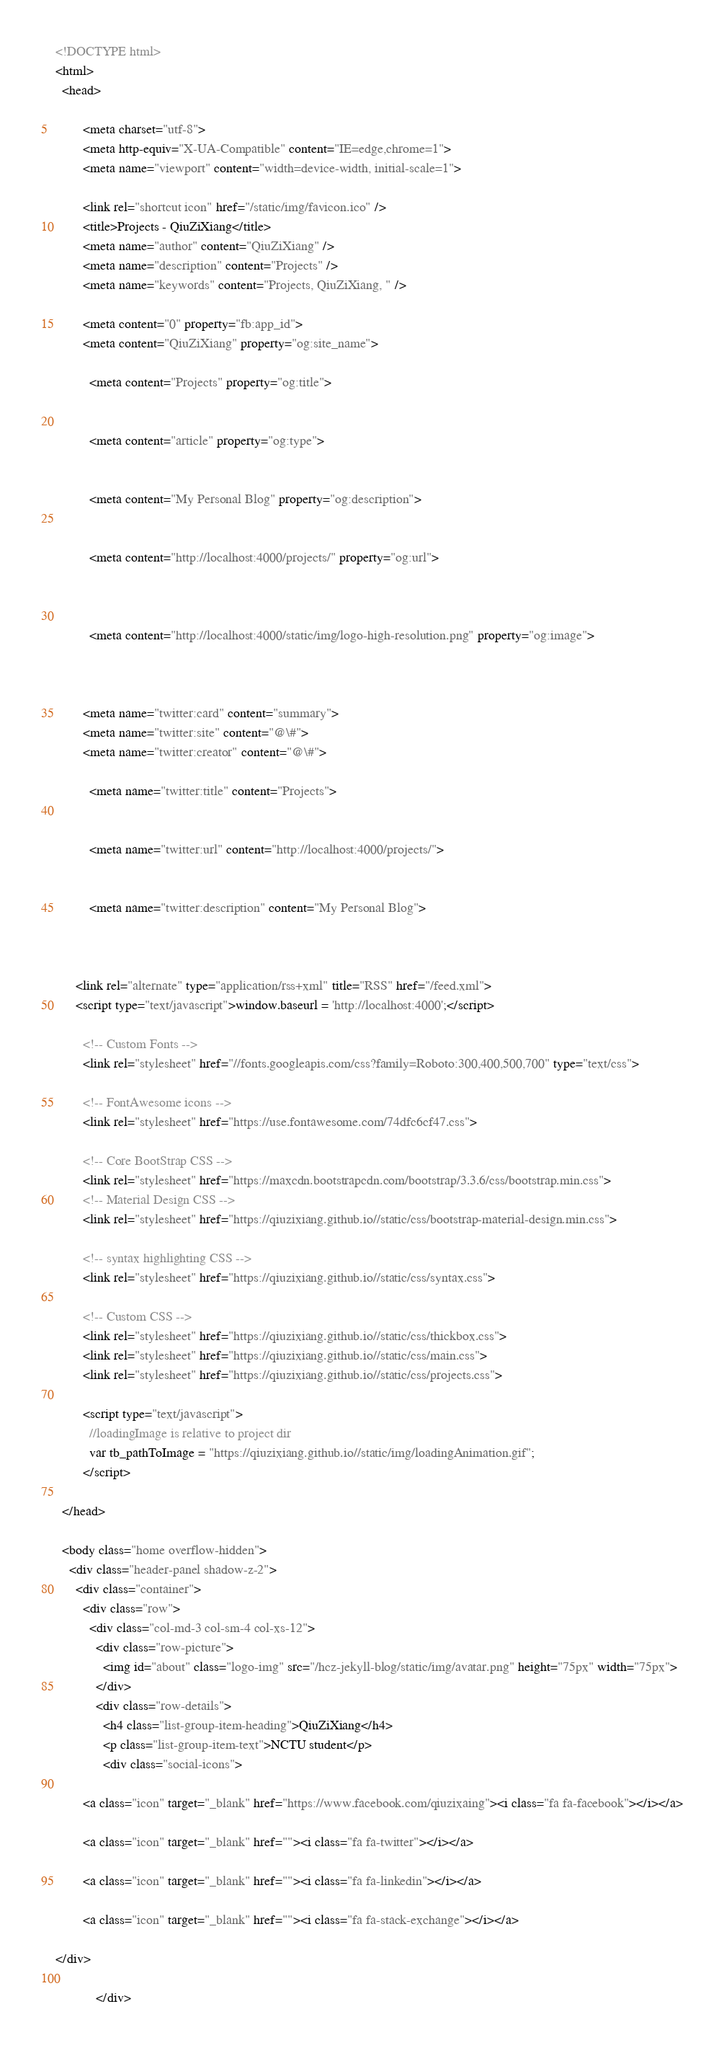Convert code to text. <code><loc_0><loc_0><loc_500><loc_500><_HTML_><!DOCTYPE html>
<html>
  <head>
    
        <meta charset="utf-8">
        <meta http-equiv="X-UA-Compatible" content="IE=edge,chrome=1">
        <meta name="viewport" content="width=device-width, initial-scale=1">

        <link rel="shortcut icon" href="/static/img/favicon.ico" />
        <title>Projects - QiuZiXiang</title>
        <meta name="author" content="QiuZiXiang" />
        <meta name="description" content="Projects" />
        <meta name="keywords" content="Projects, QiuZiXiang, " />

        <meta content="0" property="fb:app_id">
        <meta content="QiuZiXiang" property="og:site_name">
        
          <meta content="Projects" property="og:title">
        
        
          <meta content="article" property="og:type">
        
        
          <meta content="My Personal Blog" property="og:description">
        
        
          <meta content="http://localhost:4000/projects/" property="og:url">
        
        
        
          <meta content="http://localhost:4000/static/img/logo-high-resolution.png" property="og:image">
        
        
        
        <meta name="twitter:card" content="summary">
        <meta name="twitter:site" content="@\#">
        <meta name="twitter:creator" content="@\#">
        
          <meta name="twitter:title" content="Projects">
        
        
          <meta name="twitter:url" content="http://localhost:4000/projects/">
        
        
          <meta name="twitter:description" content="My Personal Blog">
        
        

      <link rel="alternate" type="application/rss+xml" title="RSS" href="/feed.xml">
      <script type="text/javascript">window.baseurl = 'http://localhost:4000';</script>
      
        <!-- Custom Fonts -->
        <link rel="stylesheet" href="//fonts.googleapis.com/css?family=Roboto:300,400,500,700" type="text/css">

        <!-- FontAwesome icons -->
        <link rel="stylesheet" href="https://use.fontawesome.com/74dfc6cf47.css">

        <!-- Core BootStrap CSS -->
        <link rel="stylesheet" href="https://maxcdn.bootstrapcdn.com/bootstrap/3.3.6/css/bootstrap.min.css">
        <!-- Material Design CSS -->
        <link rel="stylesheet" href="https://qiuzixiang.github.io//static/css/bootstrap-material-design.min.css">

        <!-- syntax highlighting CSS -->
        <link rel="stylesheet" href="https://qiuzixiang.github.io//static/css/syntax.css">

        <!-- Custom CSS -->        
        <link rel="stylesheet" href="https://qiuzixiang.github.io//static/css/thickbox.css">
        <link rel="stylesheet" href="https://qiuzixiang.github.io//static/css/main.css">
        <link rel="stylesheet" href="https://qiuzixiang.github.io//static/css/projects.css">

        <script type="text/javascript">
          //loadingImage is relative to project dir
          var tb_pathToImage = "https://qiuzixiang.github.io//static/img/loadingAnimation.gif";
        </script>

  </head>

  <body class="home overflow-hidden">
    <div class="header-panel shadow-z-2">
      <div class="container">
        <div class="row">
          <div class="col-md-3 col-sm-4 col-xs-12">
            <div class="row-picture">
              <img id="about" class="logo-img" src="/hcz-jekyll-blog/static/img/avatar.png" height="75px" width="75px">
            </div>
            <div class="row-details">
              <h4 class="list-group-item-heading">QiuZiXiang</h4>
              <p class="list-group-item-text">NCTU student</p>
              <div class="social-icons">
	
        <a class="icon" target="_blank" href="https://www.facebook.com/qiuzixaing"><i class="fa fa-facebook"></i></a>
    
        <a class="icon" target="_blank" href=""><i class="fa fa-twitter"></i></a>
    
        <a class="icon" target="_blank" href=""><i class="fa fa-linkedin"></i></a>
    
        <a class="icon" target="_blank" href=""><i class="fa fa-stack-exchange"></i></a>
    
</div>

            </div></code> 